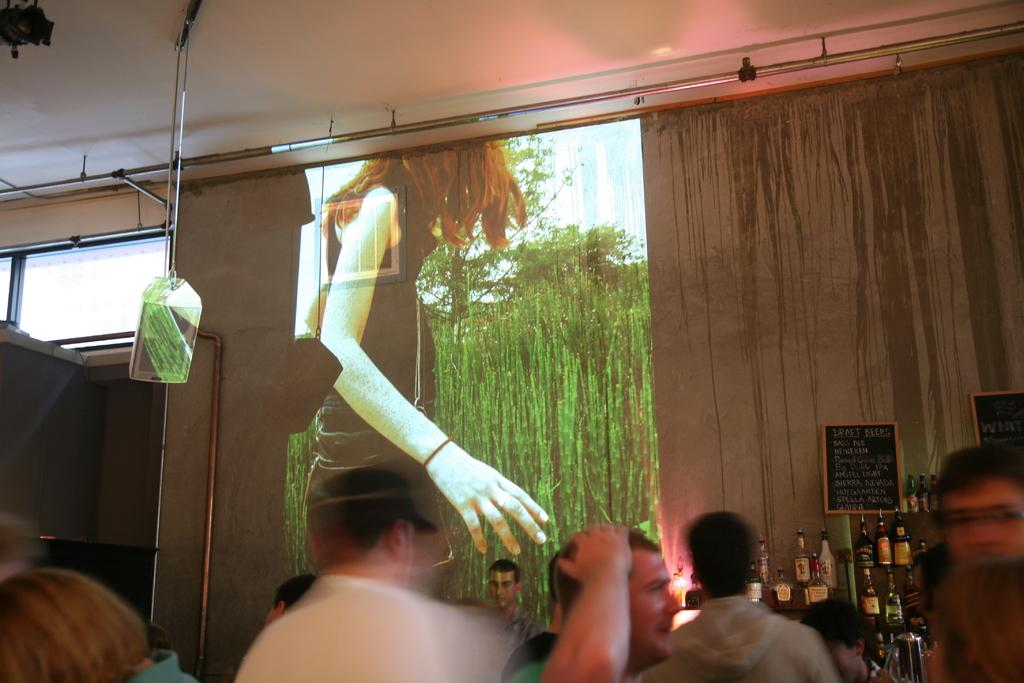What is the main feature of the image? There is a projected screen in the image. How many people are present around the screen? There are many people around the screen. What else can be seen in the image besides the screen and people? There are bottles visible in the image. What might be used for writing or displaying information in the image? There is a blackboard in the image. What type of cake is being served to the people around the screen? There is no cake present in the image; it only features a projected screen, people, bottles, and a blackboard. 